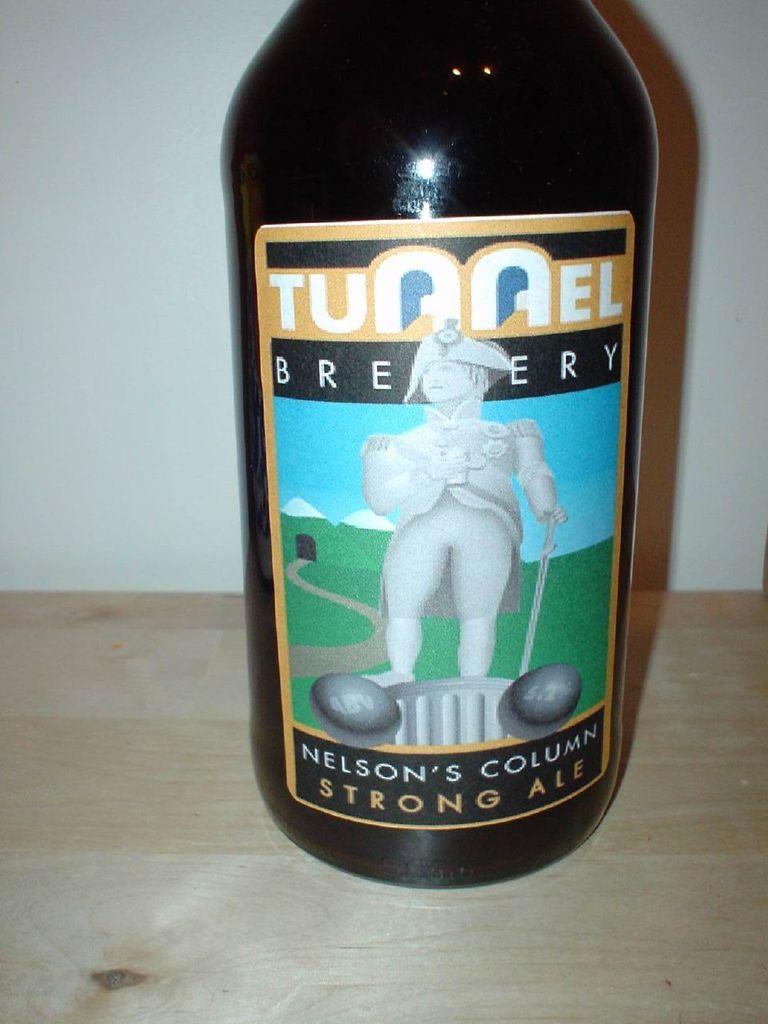What is the name of the brewery on the bottle?
Keep it short and to the point. Tunnel. 